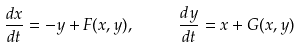Convert formula to latex. <formula><loc_0><loc_0><loc_500><loc_500>\frac { d x } { d t } = - y + F ( x , y ) , \quad \ \frac { d y } { d t } = x + G ( x , y )</formula> 